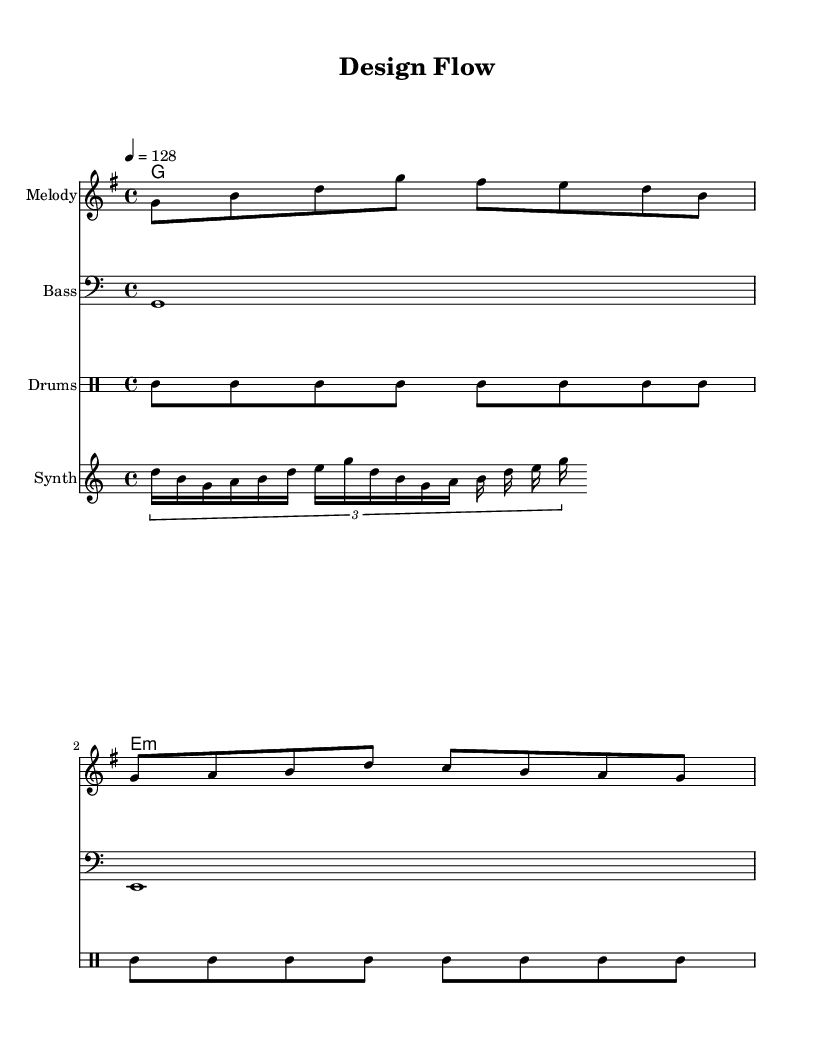What is the key signature of this music? The key signature is G major, which has one sharp (F#).
Answer: G major What is the time signature of this music? The time signature is 4/4, meaning there are four beats in each measure and the quarter note gets one beat.
Answer: 4/4 What is the tempo marking of this piece? The tempo marking indicates a speed of 128 beats per minute, as shown with the tempo marking of "4 = 128."
Answer: 128 What instrument plays the melody? The melody is played in the staff labeled "Melody," which implies it is likely played by a lead instrument like a synth or a voice.
Answer: Melody What chords are used in the harmony? The harmony section consists of a G major chord and an E minor chord as indicated in the chord names.
Answer: G major and E minor How many measures are there in the melody? There are two measures in the melody line: each group of notes separated by a vertical line indicates a measure.
Answer: 2 What rhythmic pattern is used for the drums? The drum pattern alternates between bass and hi-hat notes, following a common K-Pop drum beat structure that creates an upbeat feel.
Answer: Bass and hi-hat 